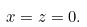Convert formula to latex. <formula><loc_0><loc_0><loc_500><loc_500>x = z = 0 .</formula> 